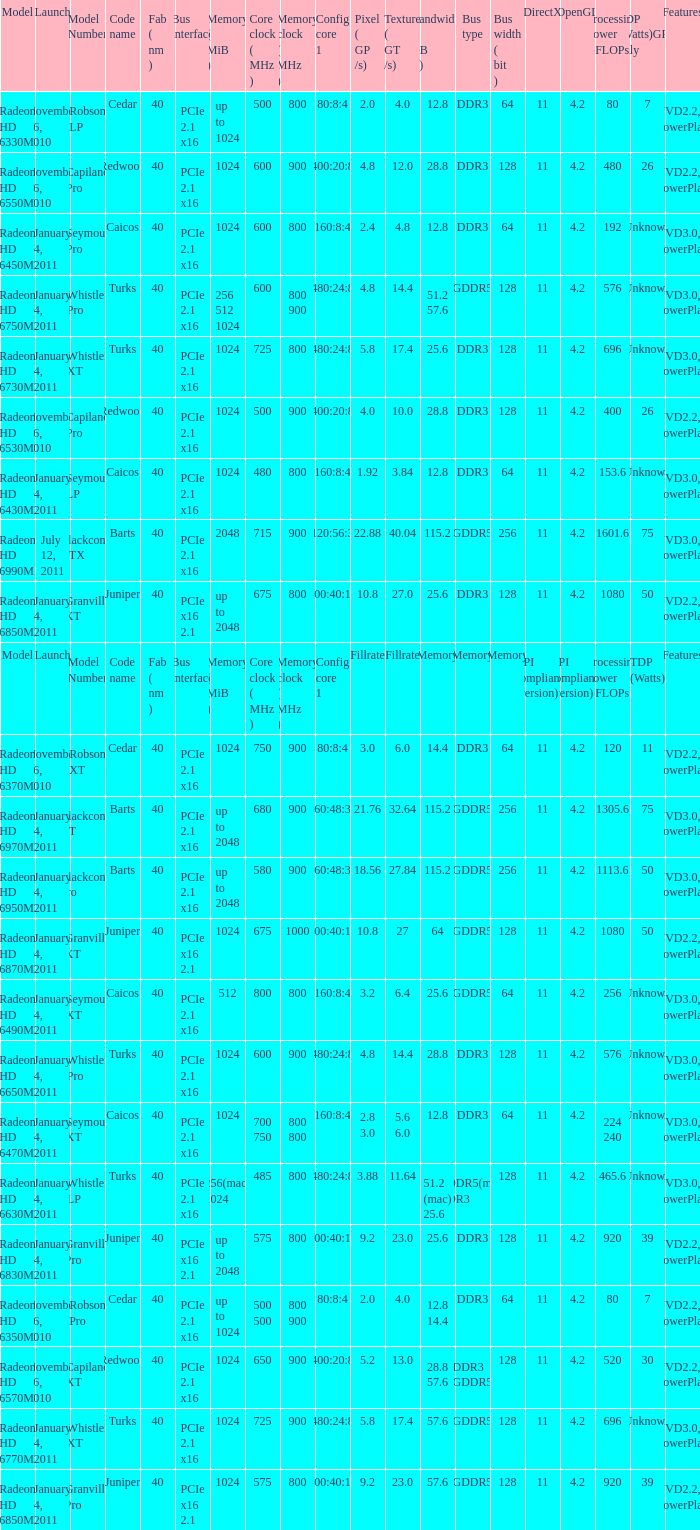How many values for fab(nm) if the model number is Whistler LP? 1.0. 